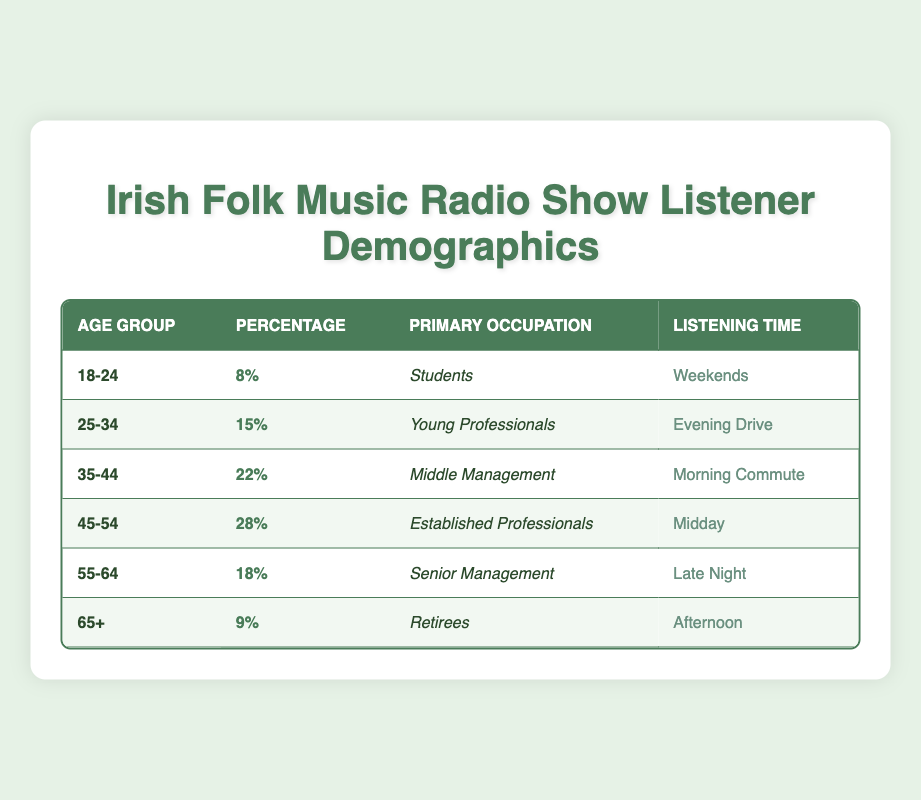What is the percentage of listeners aged 45-54? According to the table, the row corresponding to the age group 45-54 lists the percentage as 28%.
Answer: 28% Which age group has the highest percentage of listeners? The 45-54 age group has the highest percentage of 28%, according to the table.
Answer: 45-54 True or False: The majority of listeners in the 55-64 age group are Senior Management. The table states that the primary occupation for the 55-64 age group is Senior Management, so this statement is true.
Answer: True What is the listening time for the age group 35-44? Referring to the table, the listening time for the age group 35-44 is during the Morning Commute.
Answer: Morning Commute If we combine the percentages of listeners aged 18-24 and 65+, what is the total? The percentage for 18-24 is 8% and for 65+ is 9%. Adding these together: 8% + 9% = 17%.
Answer: 17% How many different primary occupations are represented in the age groups listed? By checking each age group, we find six distinct occupations: Students, Young Professionals, Middle Management, Established Professionals, Senior Management, and Retirees; that's a total of 6 different occupations.
Answer: 6 Which occupation corresponds to the age group with the lowest percentage? The age group with the lowest percentage is 18-24 at 8%, and the corresponding occupation listed is Students.
Answer: Students Is the listening time for retirees during the Morning Commute? The table indicates that retirees have their listening time during the Afternoon, so the statement is false.
Answer: False How many age groups have a percentage greater than 20%? Referring to the table, the age groups with percentages greater than 20% are 35-44 (22%), 45-54 (28%), and 55-64 (18%). Therefore, there are three age groups with a percentage greater than 20%.
Answer: 3 